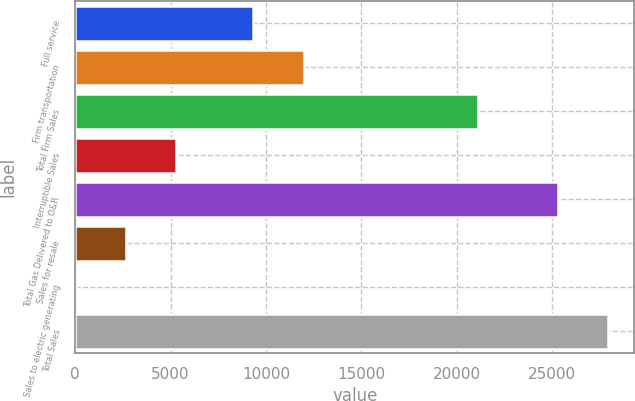Convert chart to OTSL. <chart><loc_0><loc_0><loc_500><loc_500><bar_chart><fcel>Full service<fcel>Firm transportation<fcel>Total Firm Sales<fcel>Interruptible Sales<fcel>Total Gas Delivered to O&R<fcel>Sales for resale<fcel>Sales to electric generating<fcel>Total Sales<nl><fcel>9348<fcel>11975.3<fcel>21100<fcel>5279.6<fcel>25305<fcel>2652.3<fcel>25<fcel>27932.3<nl></chart> 